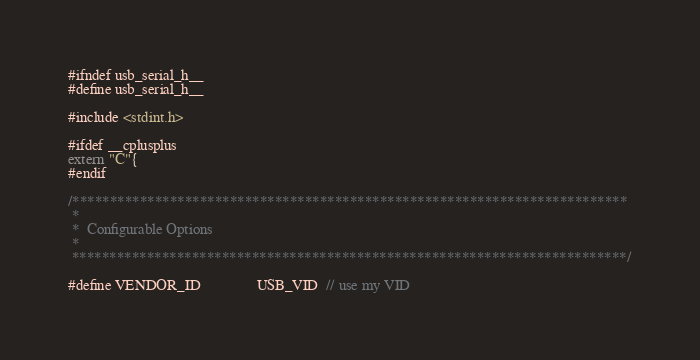Convert code to text. <code><loc_0><loc_0><loc_500><loc_500><_C_>#ifndef usb_serial_h__
#define usb_serial_h__

#include <stdint.h>

#ifdef __cplusplus
extern "C"{
#endif

/**************************************************************************
 *
 *  Configurable Options
 *
 **************************************************************************/

#define VENDOR_ID               USB_VID  // use my VID</code> 